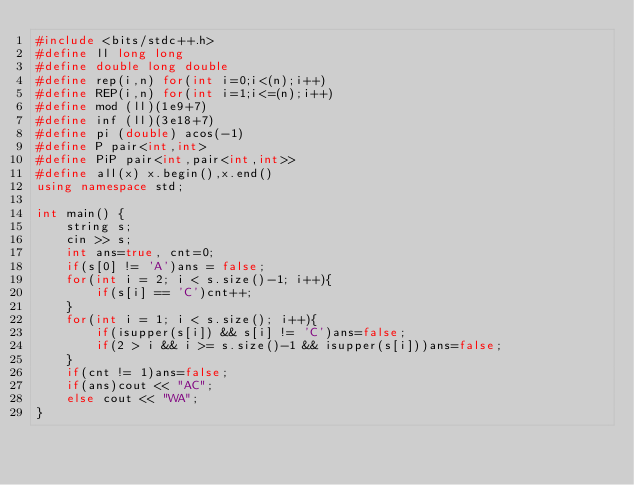<code> <loc_0><loc_0><loc_500><loc_500><_C++_>#include <bits/stdc++.h>
#define ll long long
#define double long double
#define rep(i,n) for(int i=0;i<(n);i++)
#define REP(i,n) for(int i=1;i<=(n);i++)
#define mod (ll)(1e9+7)
#define inf (ll)(3e18+7)
#define pi (double) acos(-1)
#define P pair<int,int>
#define PiP pair<int,pair<int,int>>
#define all(x) x.begin(),x.end()
using namespace std;
 
int main() {
    string s;
    cin >> s;
    int ans=true, cnt=0;
    if(s[0] != 'A')ans = false;
    for(int i = 2; i < s.size()-1; i++){
        if(s[i] == 'C')cnt++;
    }
    for(int i = 1; i < s.size(); i++){
        if(isupper(s[i]) && s[i] != 'C')ans=false;
        if(2 > i && i >= s.size()-1 && isupper(s[i]))ans=false;
    }
    if(cnt != 1)ans=false;
    if(ans)cout << "AC";
    else cout << "WA";
}</code> 